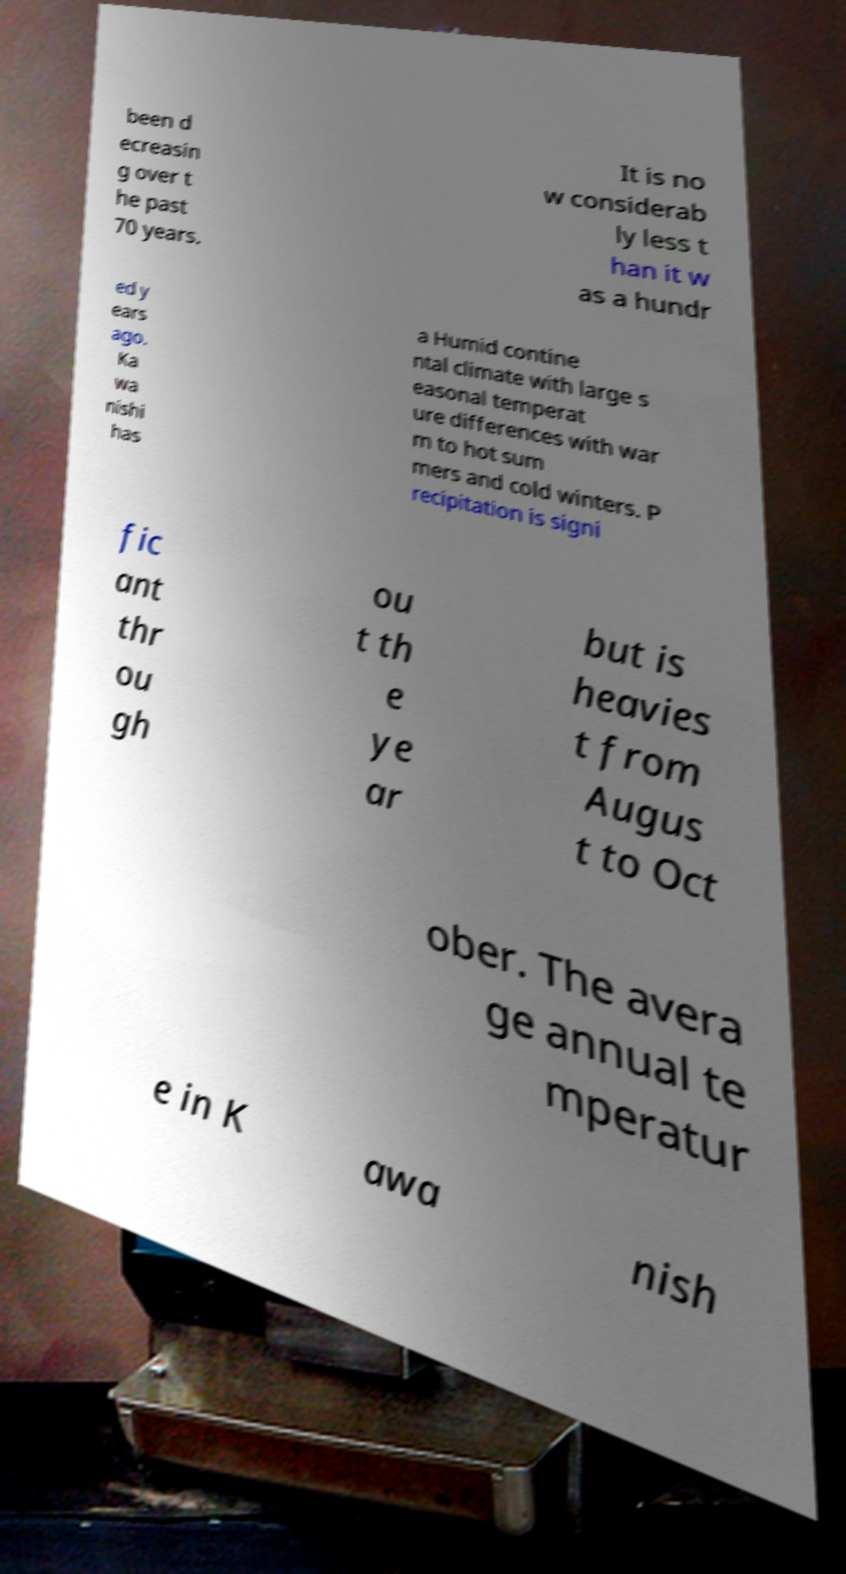Can you read and provide the text displayed in the image?This photo seems to have some interesting text. Can you extract and type it out for me? been d ecreasin g over t he past 70 years. It is no w considerab ly less t han it w as a hundr ed y ears ago. Ka wa nishi has a Humid contine ntal climate with large s easonal temperat ure differences with war m to hot sum mers and cold winters. P recipitation is signi fic ant thr ou gh ou t th e ye ar but is heavies t from Augus t to Oct ober. The avera ge annual te mperatur e in K awa nish 